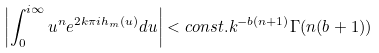<formula> <loc_0><loc_0><loc_500><loc_500>\left | \int _ { 0 } ^ { i \infty } u ^ { n } e ^ { 2 k \pi i h _ { m } ( u ) } d u \right | < c o n s t . k ^ { - b ( n + 1 ) } \Gamma ( n ( b + 1 ) )</formula> 